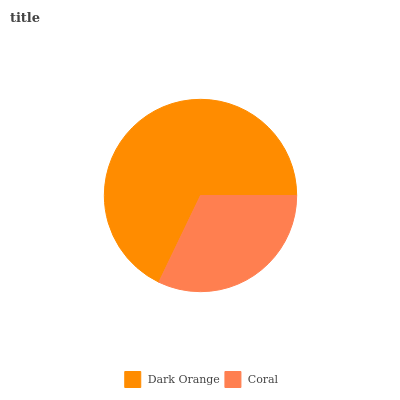Is Coral the minimum?
Answer yes or no. Yes. Is Dark Orange the maximum?
Answer yes or no. Yes. Is Coral the maximum?
Answer yes or no. No. Is Dark Orange greater than Coral?
Answer yes or no. Yes. Is Coral less than Dark Orange?
Answer yes or no. Yes. Is Coral greater than Dark Orange?
Answer yes or no. No. Is Dark Orange less than Coral?
Answer yes or no. No. Is Dark Orange the high median?
Answer yes or no. Yes. Is Coral the low median?
Answer yes or no. Yes. Is Coral the high median?
Answer yes or no. No. Is Dark Orange the low median?
Answer yes or no. No. 